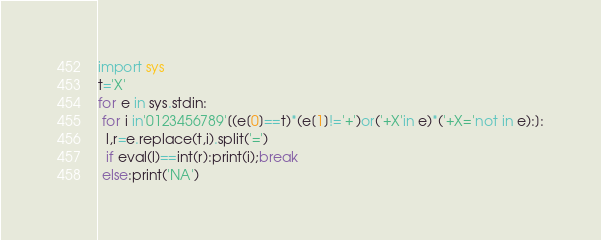Convert code to text. <code><loc_0><loc_0><loc_500><loc_500><_Python_>import sys
t='X'
for e in sys.stdin:
 for i in'0123456789'[(e[0]==t)*(e[1]!='+')or('+X'in e)*('+X='not in e):]:
  l,r=e.replace(t,i).split('=')
  if eval(l)==int(r):print(i);break
 else:print('NA')
</code> 